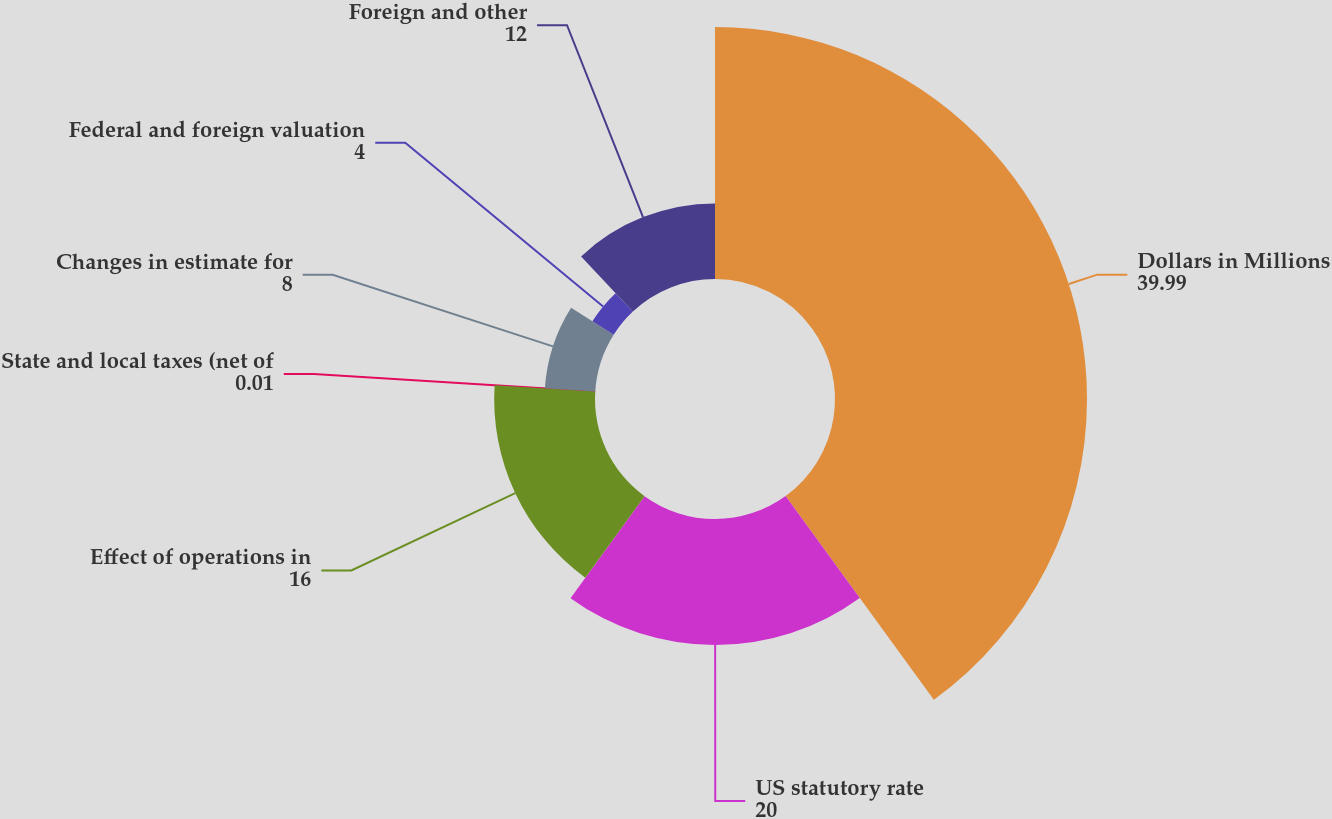<chart> <loc_0><loc_0><loc_500><loc_500><pie_chart><fcel>Dollars in Millions<fcel>US statutory rate<fcel>Effect of operations in<fcel>State and local taxes (net of<fcel>Changes in estimate for<fcel>Federal and foreign valuation<fcel>Foreign and other<nl><fcel>39.99%<fcel>20.0%<fcel>16.0%<fcel>0.01%<fcel>8.0%<fcel>4.0%<fcel>12.0%<nl></chart> 